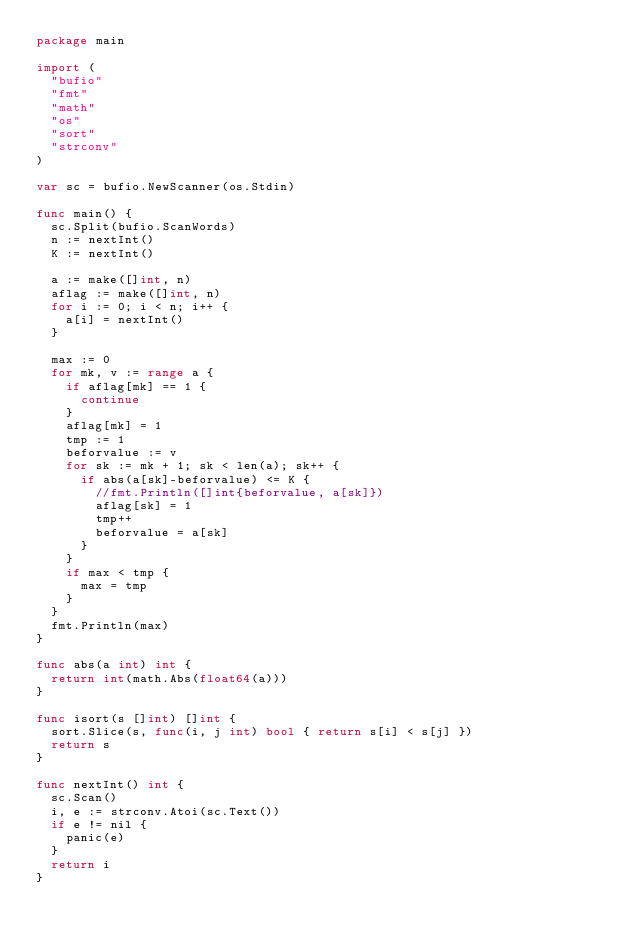Convert code to text. <code><loc_0><loc_0><loc_500><loc_500><_Go_>package main

import (
	"bufio"
	"fmt"
	"math"
	"os"
	"sort"
	"strconv"
)

var sc = bufio.NewScanner(os.Stdin)

func main() {
	sc.Split(bufio.ScanWords)
	n := nextInt()
	K := nextInt()

	a := make([]int, n)
	aflag := make([]int, n)
	for i := 0; i < n; i++ {
		a[i] = nextInt()
	}

	max := 0
	for mk, v := range a {
		if aflag[mk] == 1 {
			continue
		}
		aflag[mk] = 1
		tmp := 1
		beforvalue := v
		for sk := mk + 1; sk < len(a); sk++ {
			if abs(a[sk]-beforvalue) <= K {
				//fmt.Println([]int{beforvalue, a[sk]})
				aflag[sk] = 1
				tmp++
				beforvalue = a[sk]
			}
		}
		if max < tmp {
			max = tmp
		}
	}
	fmt.Println(max)
}

func abs(a int) int {
	return int(math.Abs(float64(a)))
}

func isort(s []int) []int {
	sort.Slice(s, func(i, j int) bool { return s[i] < s[j] })
	return s
}

func nextInt() int {
	sc.Scan()
	i, e := strconv.Atoi(sc.Text())
	if e != nil {
		panic(e)
	}
	return i
}
</code> 